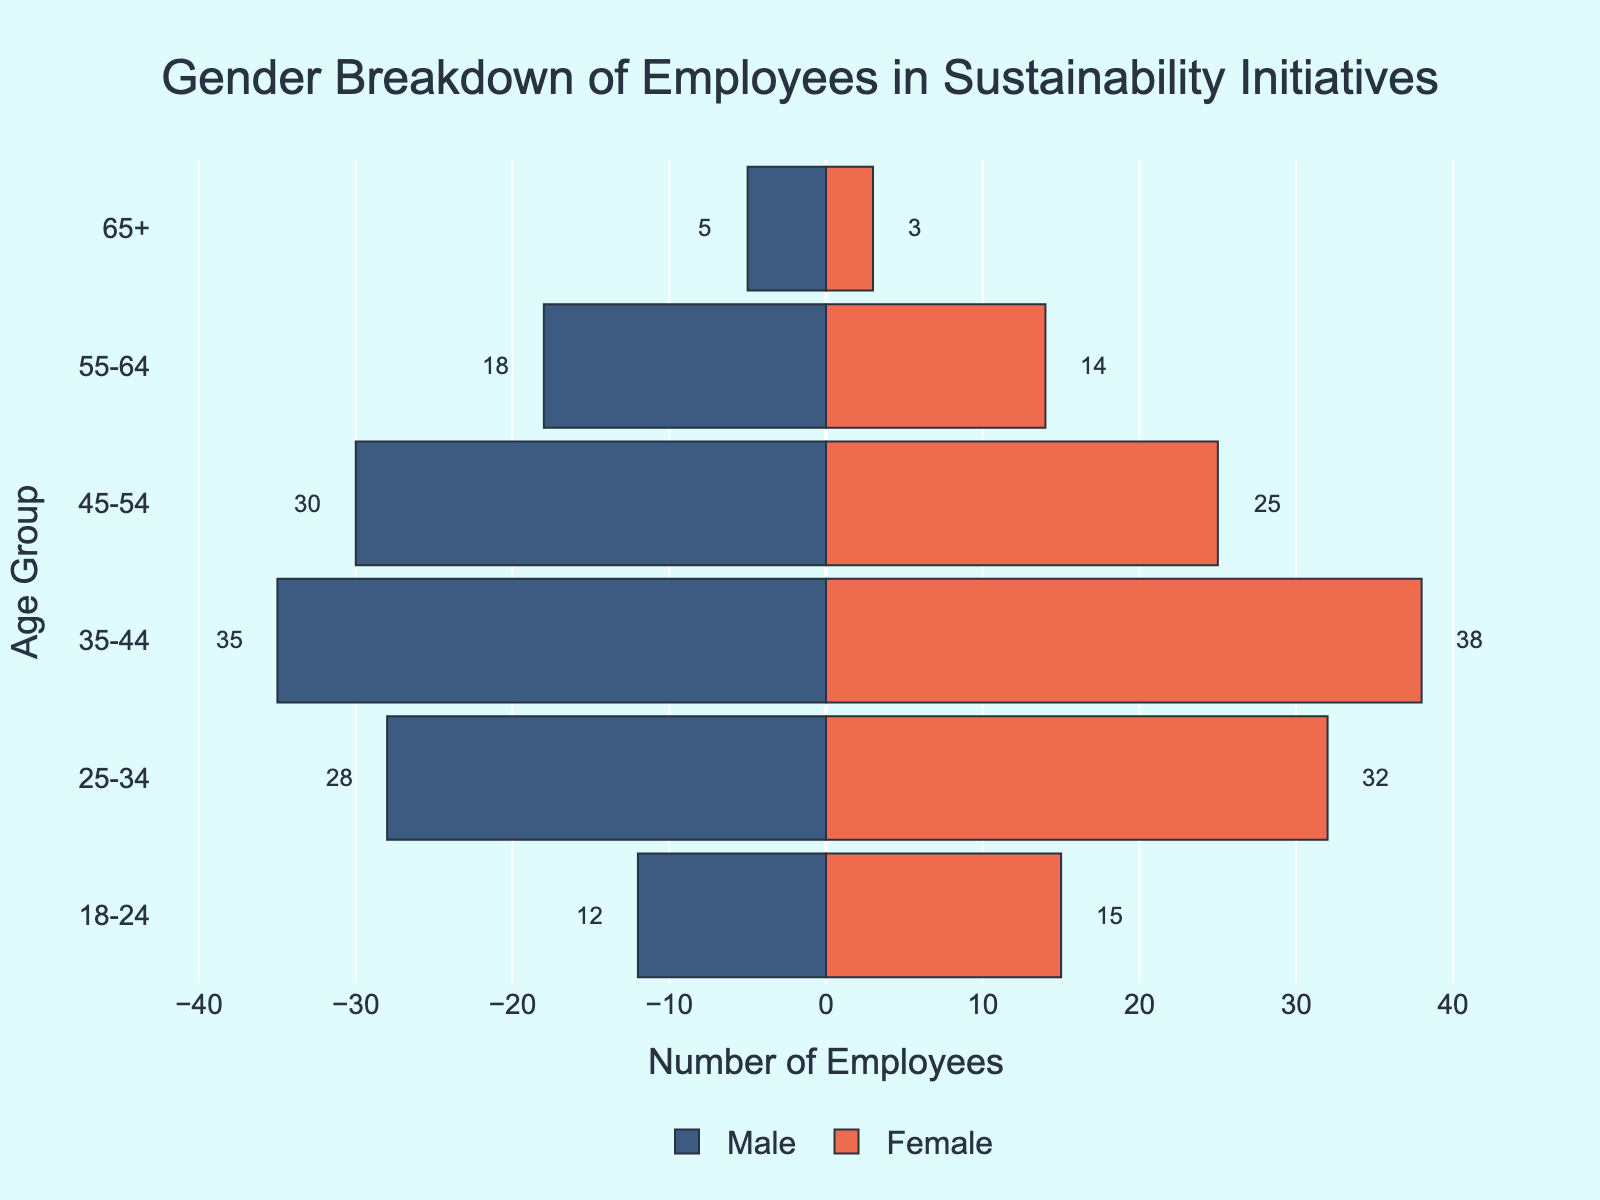What age group has the highest number of female employees? To find the age group with the highest number of female employees, look for the highest bar on the female (right) side of the chart. The age group 35-44 has 38 female employees, which is the highest.
Answer: 35-44 What is the total number of male employees across all age groups? Sum the values of male employees in each age group: 12 (18-24) + 28 (25-34) + 35 (35-44) + 30 (45-54) + 18 (55-64) + 5 (65+). This equals 128.
Answer: 128 Which age group has more male than female employees, and what is the difference? Check the length of bars for each age group's males and females. The 45-54 age group has more males (30) than females (25). The difference is 30 - 25 = 5.
Answer: 45-54, 5 Compare the number of male and female employees in the 55-64 age group. Who has more, and by how much? In the 55-64 age group, there are 18 male employees and 14 female employees. The males outnumber females by 18 - 14 = 4.
Answer: Males, 4 What's the average number of female employees per age group? Add up the number of female employees across all age groups and divide by the number of age groups. The total is 15 (18-24) + 32 (25-34) + 38 (35-44) + 25 (45-54) + 14 (55-64) + 3 (65+), which sums up to 127. There are 6 age groups, so the average is 127 / 6 ≈ 21.17.
Answer: 21.17 What is the gender distribution in the 25-34 age group? For the 25-34 age group, there are 28 male employees and 32 female employees. This shows more females than males by a count of 4.
Answer: 28 males and 32 females Which age group has the least number of employees overall, and what is the total number? To find the age group with the least total employees, sum both male and female employees for each group. The 65+ age group has 5 males and 3 females, totaling 8 employees, which is the lowest.
Answer: 65+, 8 Are there more male employees in the 35-44 age group or the 55-64 age group? Comparing the number of males in each group, the 35-44 age group has 35 male employees, and the 55-64 age group has 18 male employees. There are more males in the 35-44 age group.
Answer: 35-44 What is the ratio of male to female employees in the 18-24 age group? In the 18-24 age group, there are 12 male employees and 15 female employees. The ratio of males to females is 12:15, which simplifies to 4:5.
Answer: 4:5 